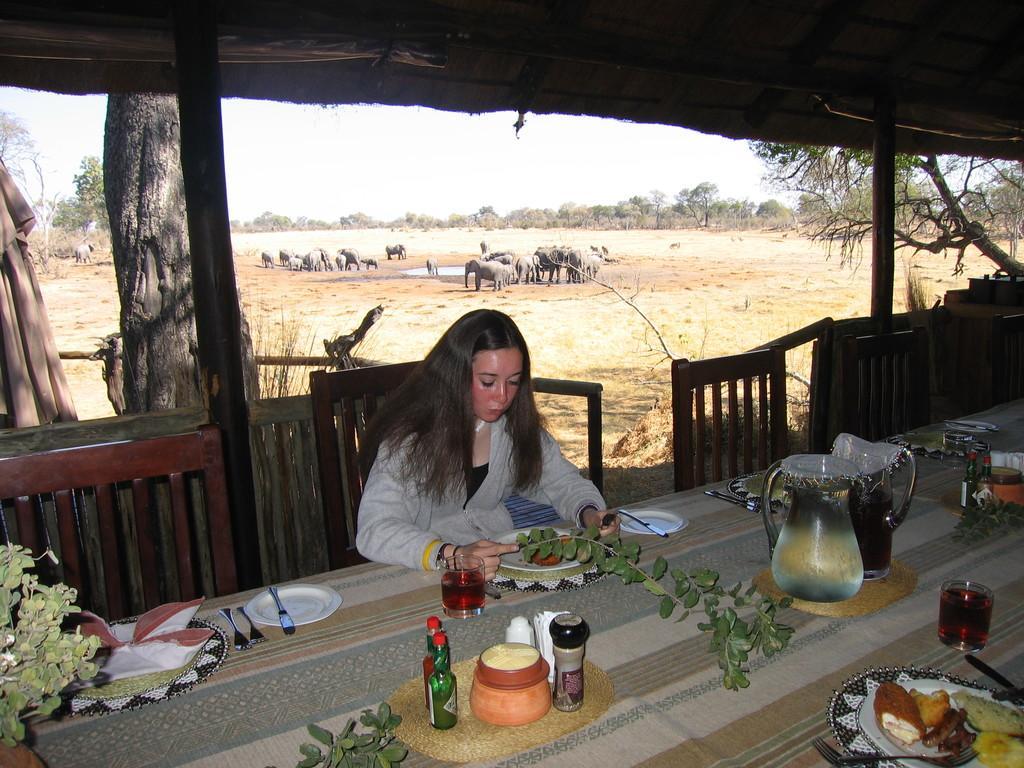Please provide a concise description of this image. There is a dining table and chairs. And a lady is sitting on the chair. On the table there are plates, forks, mats, knives, spoons, bottles, glasses, jugs and some plants. On the plates there are food items. There are pillars. In the back there are trees, elephants and sky. 